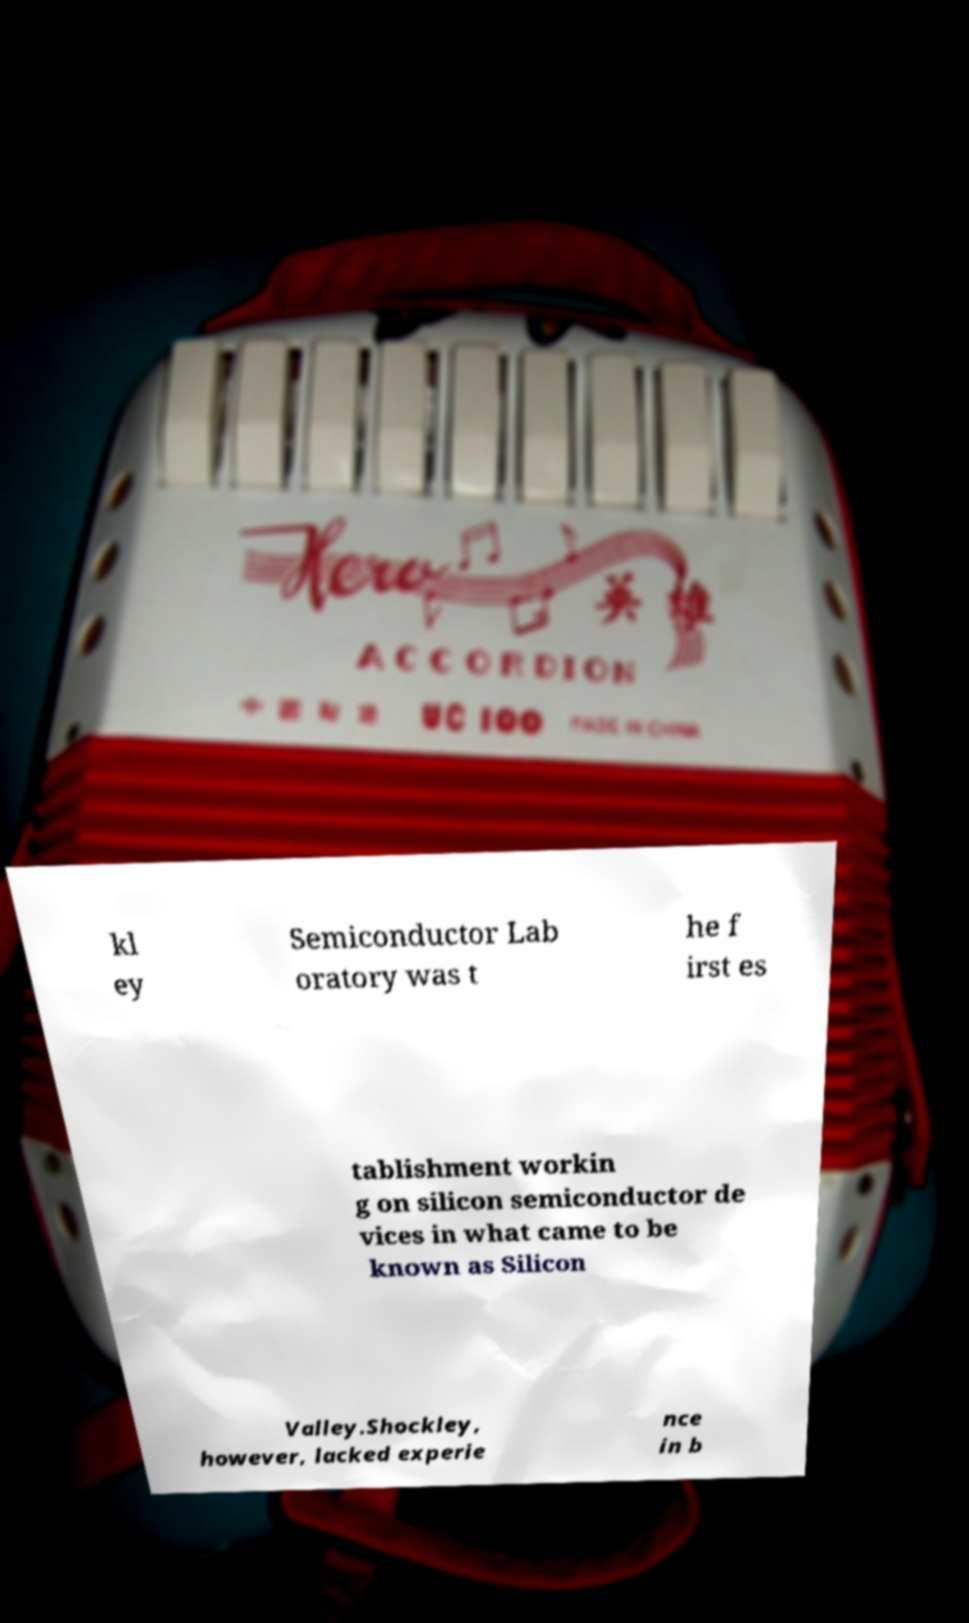There's text embedded in this image that I need extracted. Can you transcribe it verbatim? kl ey Semiconductor Lab oratory was t he f irst es tablishment workin g on silicon semiconductor de vices in what came to be known as Silicon Valley.Shockley, however, lacked experie nce in b 